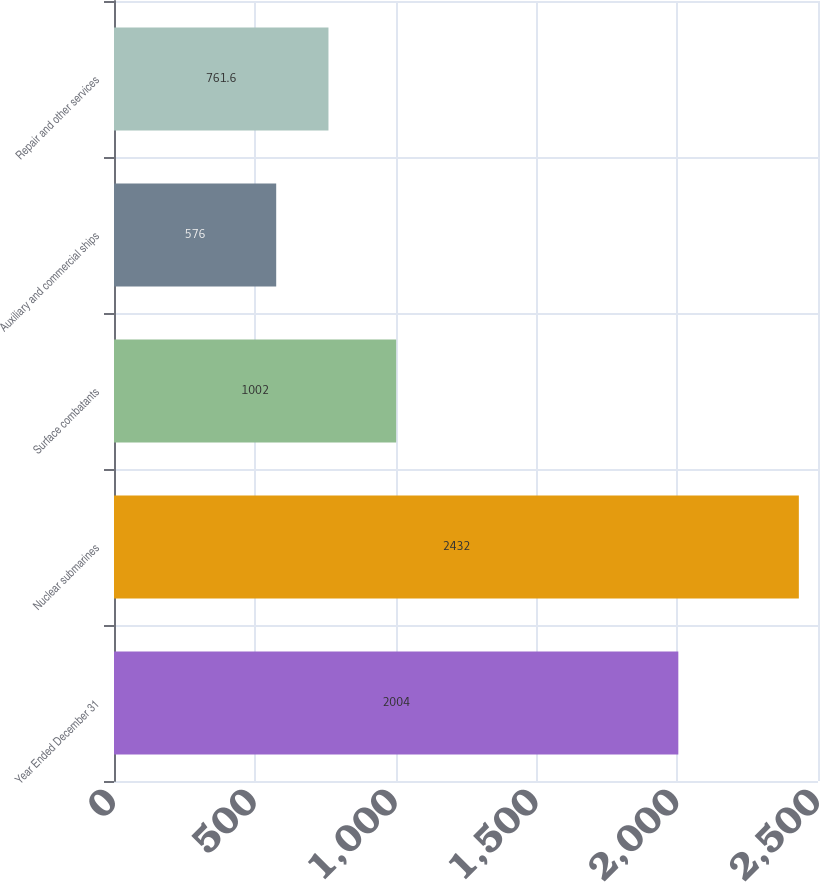<chart> <loc_0><loc_0><loc_500><loc_500><bar_chart><fcel>Year Ended December 31<fcel>Nuclear submarines<fcel>Surface combatants<fcel>Auxiliary and commercial ships<fcel>Repair and other services<nl><fcel>2004<fcel>2432<fcel>1002<fcel>576<fcel>761.6<nl></chart> 